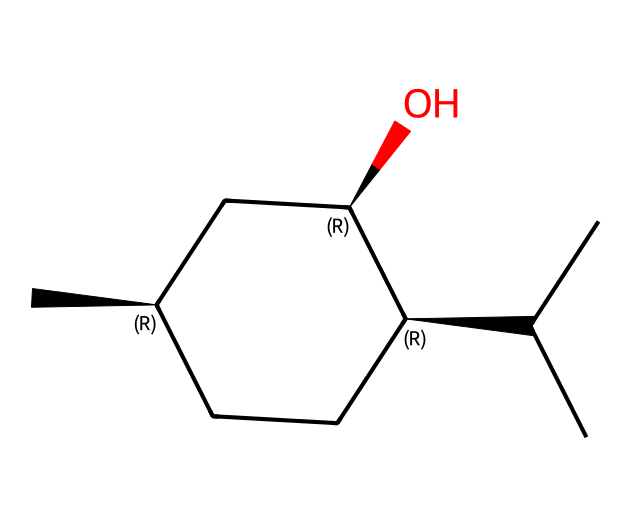What is the molecular formula of menthol represented by the SMILES? To get the molecular formula, count the carbon (C), hydrogen (H), and oxygen (O) atoms from the given SMILES. The structure has 10 carbons, 20 hydrogens, and 1 oxygen, giving the formula: C10H20O.
Answer: C10H20O How many chiral centers are present in the molecular structure of menthol? The chiral centers are indicated by the "@" symbols in the SMILES notation. There are three "@" symbols, suggesting that there are three chiral centers in menthol.
Answer: 3 What is the stereochemistry at the chiral centers of menthol? The chiral centers in the SMILES are marked with "@" and indicate the configuration - according to the SMILES, the stereochemistry for these centers is S at one and R at the other two, reflecting their specific 3D arrangements.
Answer: S, R, R Is menthol a type of terpenoid or alkaloid? Menthol is classified as a terpenoid, specifically a monoterpene, due to its biosynthetic origin from isoprene units and the structure which is characteristic of terpenes.
Answer: terpenoid How many rings are present in the structure of menthol? The SMILES indicates a cyclic structure, where "CC[C@H]" suggests a ring is formed by the atoms. There is one ring in the chemical structure of menthol.
Answer: 1 What type of functional group is present in menthol? The presence of the "O" in conjunction with "C" suggests that menthol contains a hydroxyl (-OH) functional group, which is characteristic of alcohols.
Answer: hydroxyl Does menthol exhibit optical activity? Yes, menthol exhibits optical activity due to the presence of three chiral centers in its structure, allowing it to rotate plane-polarized light.
Answer: Yes 